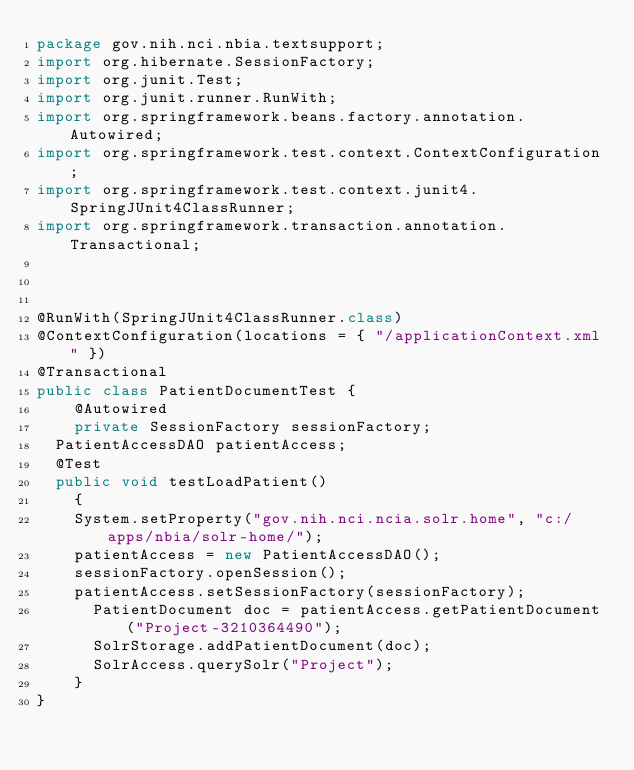Convert code to text. <code><loc_0><loc_0><loc_500><loc_500><_Java_>package gov.nih.nci.nbia.textsupport;
import org.hibernate.SessionFactory;
import org.junit.Test;
import org.junit.runner.RunWith;
import org.springframework.beans.factory.annotation.Autowired;
import org.springframework.test.context.ContextConfiguration;
import org.springframework.test.context.junit4.SpringJUnit4ClassRunner;
import org.springframework.transaction.annotation.Transactional;



@RunWith(SpringJUnit4ClassRunner.class)
@ContextConfiguration(locations = { "/applicationContext.xml" })
@Transactional 
public class PatientDocumentTest {
    @Autowired
    private SessionFactory sessionFactory;
	PatientAccessDAO patientAccess;
	@Test
	public void testLoadPatient()
    {
		System.setProperty("gov.nih.nci.ncia.solr.home", "c:/apps/nbia/solr-home/");
		patientAccess = new PatientAccessDAO();
		sessionFactory.openSession();
		patientAccess.setSessionFactory(sessionFactory);
    	PatientDocument doc = patientAccess.getPatientDocument("Project-3210364490");
    	SolrStorage.addPatientDocument(doc);
    	SolrAccess.querySolr("Project");
    }
}
</code> 